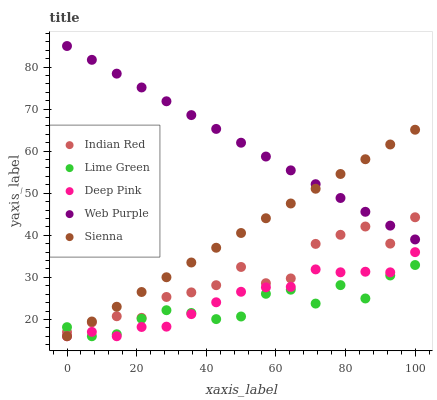Does Lime Green have the minimum area under the curve?
Answer yes or no. Yes. Does Web Purple have the maximum area under the curve?
Answer yes or no. Yes. Does Deep Pink have the minimum area under the curve?
Answer yes or no. No. Does Deep Pink have the maximum area under the curve?
Answer yes or no. No. Is Sienna the smoothest?
Answer yes or no. Yes. Is Indian Red the roughest?
Answer yes or no. Yes. Is Web Purple the smoothest?
Answer yes or no. No. Is Web Purple the roughest?
Answer yes or no. No. Does Sienna have the lowest value?
Answer yes or no. Yes. Does Web Purple have the lowest value?
Answer yes or no. No. Does Web Purple have the highest value?
Answer yes or no. Yes. Does Deep Pink have the highest value?
Answer yes or no. No. Is Lime Green less than Web Purple?
Answer yes or no. Yes. Is Web Purple greater than Deep Pink?
Answer yes or no. Yes. Does Sienna intersect Indian Red?
Answer yes or no. Yes. Is Sienna less than Indian Red?
Answer yes or no. No. Is Sienna greater than Indian Red?
Answer yes or no. No. Does Lime Green intersect Web Purple?
Answer yes or no. No. 